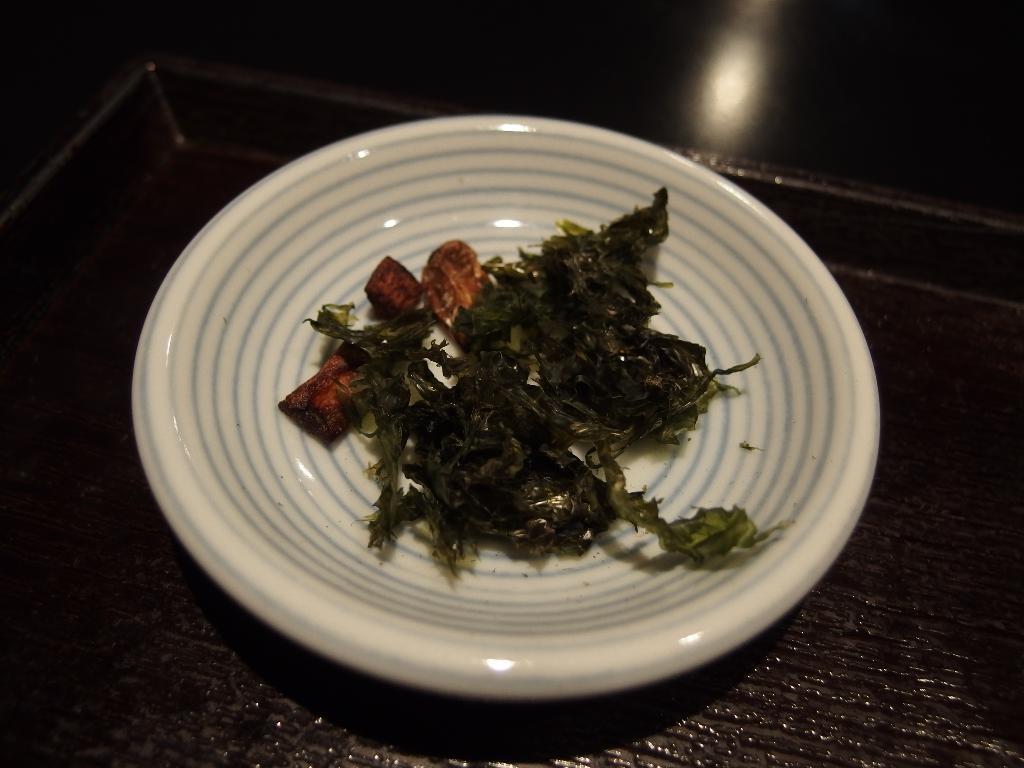Could you give a brief overview of what you see in this image? In this picture we can see food in a plate and the plate is on the tray. Behind the tree, there is a dark background and light. 